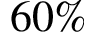<formula> <loc_0><loc_0><loc_500><loc_500>6 0 \%</formula> 